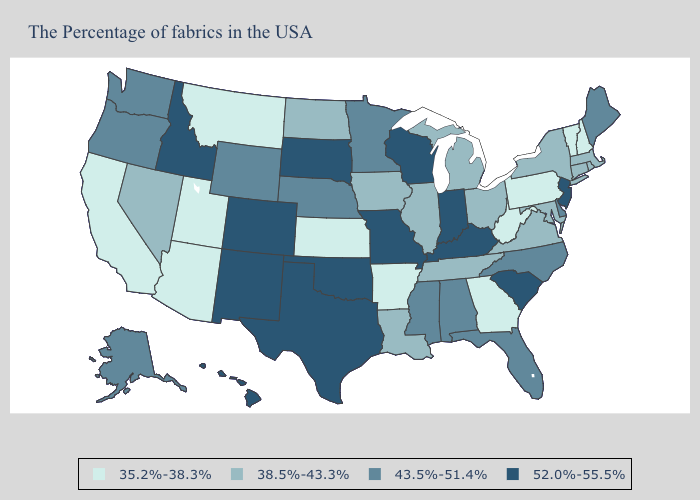Does Pennsylvania have the highest value in the Northeast?
Keep it brief. No. Name the states that have a value in the range 38.5%-43.3%?
Concise answer only. Massachusetts, Rhode Island, Connecticut, New York, Maryland, Virginia, Ohio, Michigan, Tennessee, Illinois, Louisiana, Iowa, North Dakota, Nevada. Does Minnesota have the lowest value in the MidWest?
Short answer required. No. What is the lowest value in states that border Kansas?
Give a very brief answer. 43.5%-51.4%. Does New York have the lowest value in the USA?
Write a very short answer. No. Which states have the highest value in the USA?
Quick response, please. New Jersey, South Carolina, Kentucky, Indiana, Wisconsin, Missouri, Oklahoma, Texas, South Dakota, Colorado, New Mexico, Idaho, Hawaii. Among the states that border Ohio , which have the highest value?
Concise answer only. Kentucky, Indiana. Which states hav the highest value in the West?
Keep it brief. Colorado, New Mexico, Idaho, Hawaii. Which states have the highest value in the USA?
Quick response, please. New Jersey, South Carolina, Kentucky, Indiana, Wisconsin, Missouri, Oklahoma, Texas, South Dakota, Colorado, New Mexico, Idaho, Hawaii. What is the value of Alabama?
Answer briefly. 43.5%-51.4%. What is the value of Louisiana?
Write a very short answer. 38.5%-43.3%. What is the lowest value in states that border West Virginia?
Keep it brief. 35.2%-38.3%. Name the states that have a value in the range 38.5%-43.3%?
Quick response, please. Massachusetts, Rhode Island, Connecticut, New York, Maryland, Virginia, Ohio, Michigan, Tennessee, Illinois, Louisiana, Iowa, North Dakota, Nevada. Does the map have missing data?
Keep it brief. No. 